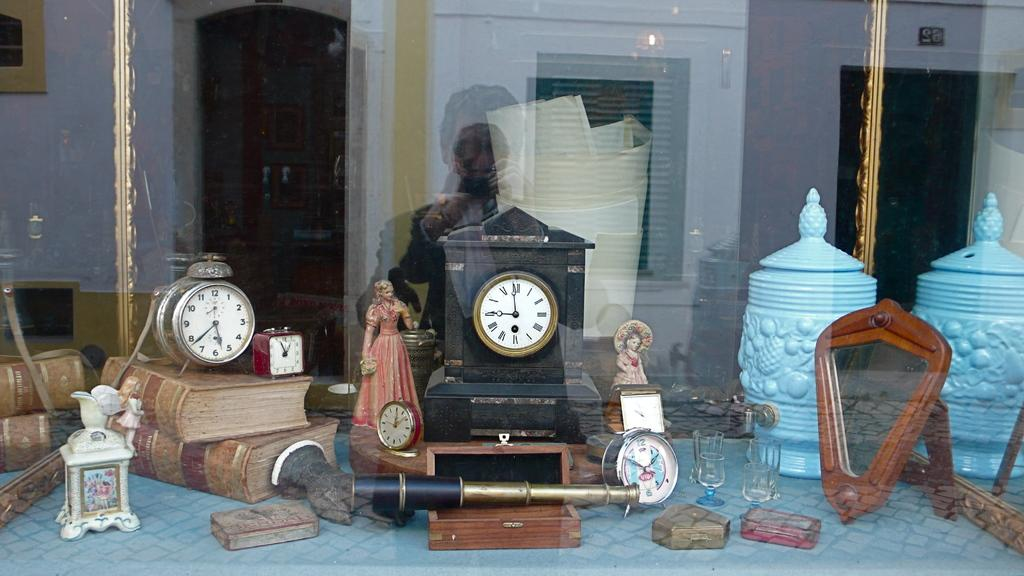<image>
Give a short and clear explanation of the subsequent image. Several vintage clocks are displayed in a window and a black one shows the time is 9:00. 